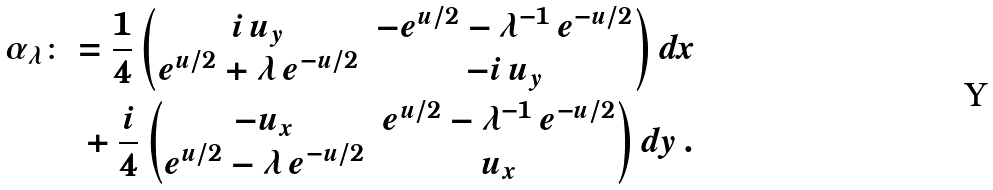<formula> <loc_0><loc_0><loc_500><loc_500>\alpha _ { \lambda } & \colon = \frac { 1 } { 4 } \begin{pmatrix} i \, u _ { y } & - e ^ { u / 2 } - \lambda ^ { - 1 } \, e ^ { - u / 2 } \\ e ^ { u / 2 } + \lambda \, e ^ { - u / 2 } & - i \, u _ { y } \end{pmatrix} d x \\ & \quad + \frac { i } { 4 } \begin{pmatrix} - u _ { x } & e ^ { u / 2 } - \lambda ^ { - 1 } \, e ^ { - u / 2 } \\ e ^ { u / 2 } - \lambda \, e ^ { - u / 2 } & u _ { x } \end{pmatrix} d y \, .</formula> 